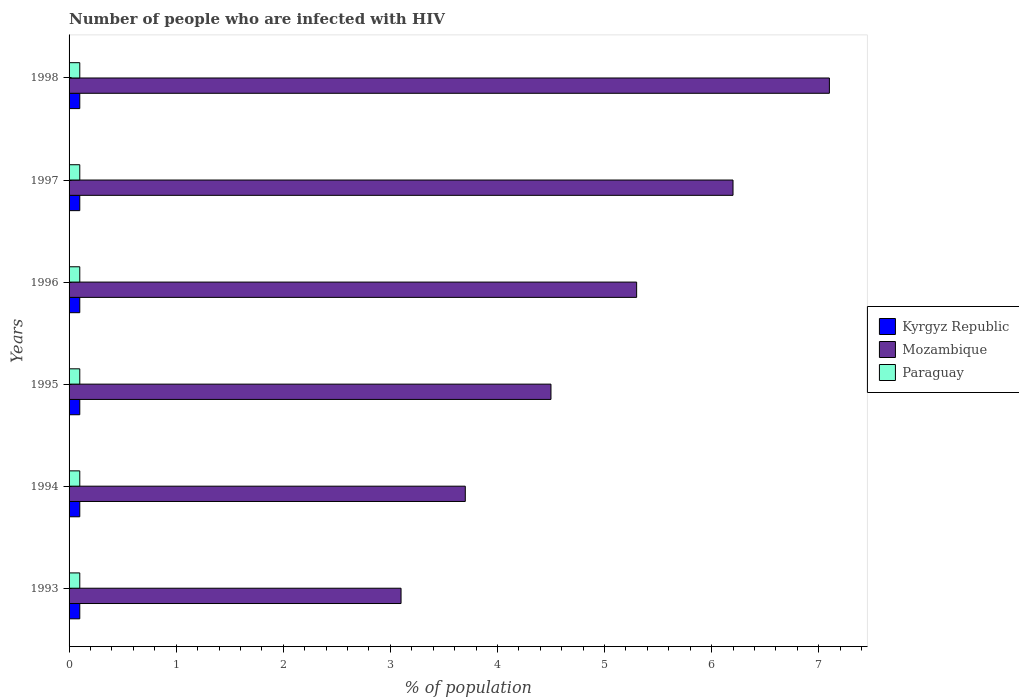How many groups of bars are there?
Offer a very short reply. 6. Are the number of bars per tick equal to the number of legend labels?
Your answer should be compact. Yes. Are the number of bars on each tick of the Y-axis equal?
Your response must be concise. Yes. How many bars are there on the 3rd tick from the top?
Give a very brief answer. 3. In how many cases, is the number of bars for a given year not equal to the number of legend labels?
Give a very brief answer. 0. What is the percentage of HIV infected population in in Kyrgyz Republic in 1994?
Make the answer very short. 0.1. Across all years, what is the maximum percentage of HIV infected population in in Mozambique?
Give a very brief answer. 7.1. Across all years, what is the minimum percentage of HIV infected population in in Kyrgyz Republic?
Keep it short and to the point. 0.1. What is the difference between the percentage of HIV infected population in in Kyrgyz Republic in 1998 and the percentage of HIV infected population in in Paraguay in 1997?
Give a very brief answer. 0. What is the average percentage of HIV infected population in in Paraguay per year?
Offer a terse response. 0.1. In how many years, is the percentage of HIV infected population in in Mozambique greater than 4 %?
Your answer should be compact. 4. Is the percentage of HIV infected population in in Paraguay in 1994 less than that in 1995?
Ensure brevity in your answer.  No. What is the difference between the highest and the second highest percentage of HIV infected population in in Mozambique?
Offer a terse response. 0.9. What is the difference between the highest and the lowest percentage of HIV infected population in in Kyrgyz Republic?
Provide a short and direct response. 0. Is the sum of the percentage of HIV infected population in in Mozambique in 1995 and 1998 greater than the maximum percentage of HIV infected population in in Paraguay across all years?
Your response must be concise. Yes. What does the 1st bar from the top in 1995 represents?
Provide a short and direct response. Paraguay. What does the 1st bar from the bottom in 1993 represents?
Your answer should be very brief. Kyrgyz Republic. Are all the bars in the graph horizontal?
Make the answer very short. Yes. How many years are there in the graph?
Offer a very short reply. 6. Are the values on the major ticks of X-axis written in scientific E-notation?
Give a very brief answer. No. Does the graph contain grids?
Your answer should be compact. No. How are the legend labels stacked?
Your response must be concise. Vertical. What is the title of the graph?
Ensure brevity in your answer.  Number of people who are infected with HIV. Does "Belgium" appear as one of the legend labels in the graph?
Make the answer very short. No. What is the label or title of the X-axis?
Provide a succinct answer. % of population. What is the % of population of Kyrgyz Republic in 1993?
Give a very brief answer. 0.1. What is the % of population in Paraguay in 1993?
Ensure brevity in your answer.  0.1. What is the % of population in Kyrgyz Republic in 1994?
Your answer should be compact. 0.1. What is the % of population in Paraguay in 1994?
Your answer should be compact. 0.1. What is the % of population of Kyrgyz Republic in 1995?
Offer a terse response. 0.1. What is the % of population in Mozambique in 1996?
Give a very brief answer. 5.3. What is the % of population of Kyrgyz Republic in 1997?
Offer a very short reply. 0.1. What is the % of population in Paraguay in 1997?
Provide a short and direct response. 0.1. What is the % of population of Kyrgyz Republic in 1998?
Make the answer very short. 0.1. Across all years, what is the maximum % of population of Kyrgyz Republic?
Your response must be concise. 0.1. Across all years, what is the maximum % of population in Mozambique?
Offer a terse response. 7.1. Across all years, what is the minimum % of population in Paraguay?
Make the answer very short. 0.1. What is the total % of population in Kyrgyz Republic in the graph?
Provide a succinct answer. 0.6. What is the total % of population in Mozambique in the graph?
Keep it short and to the point. 29.9. What is the difference between the % of population of Kyrgyz Republic in 1993 and that in 1994?
Your response must be concise. 0. What is the difference between the % of population in Paraguay in 1993 and that in 1994?
Offer a terse response. 0. What is the difference between the % of population of Mozambique in 1993 and that in 1995?
Your answer should be compact. -1.4. What is the difference between the % of population in Kyrgyz Republic in 1993 and that in 1996?
Ensure brevity in your answer.  0. What is the difference between the % of population in Paraguay in 1993 and that in 1996?
Provide a succinct answer. 0. What is the difference between the % of population in Mozambique in 1993 and that in 1997?
Offer a terse response. -3.1. What is the difference between the % of population in Paraguay in 1993 and that in 1997?
Provide a short and direct response. 0. What is the difference between the % of population of Mozambique in 1993 and that in 1998?
Offer a terse response. -4. What is the difference between the % of population of Paraguay in 1993 and that in 1998?
Your response must be concise. 0. What is the difference between the % of population in Mozambique in 1994 and that in 1995?
Give a very brief answer. -0.8. What is the difference between the % of population in Paraguay in 1994 and that in 1995?
Provide a short and direct response. 0. What is the difference between the % of population of Kyrgyz Republic in 1994 and that in 1996?
Offer a terse response. 0. What is the difference between the % of population in Mozambique in 1994 and that in 1996?
Offer a very short reply. -1.6. What is the difference between the % of population of Paraguay in 1994 and that in 1996?
Provide a short and direct response. 0. What is the difference between the % of population of Mozambique in 1994 and that in 1997?
Your answer should be very brief. -2.5. What is the difference between the % of population in Paraguay in 1994 and that in 1997?
Offer a terse response. 0. What is the difference between the % of population in Kyrgyz Republic in 1994 and that in 1998?
Your response must be concise. 0. What is the difference between the % of population of Mozambique in 1995 and that in 1996?
Keep it short and to the point. -0.8. What is the difference between the % of population of Kyrgyz Republic in 1995 and that in 1997?
Provide a succinct answer. 0. What is the difference between the % of population in Paraguay in 1995 and that in 1997?
Your answer should be compact. 0. What is the difference between the % of population of Paraguay in 1995 and that in 1998?
Provide a short and direct response. 0. What is the difference between the % of population of Mozambique in 1996 and that in 1997?
Keep it short and to the point. -0.9. What is the difference between the % of population in Paraguay in 1996 and that in 1997?
Give a very brief answer. 0. What is the difference between the % of population of Kyrgyz Republic in 1996 and that in 1998?
Offer a very short reply. 0. What is the difference between the % of population in Mozambique in 1996 and that in 1998?
Offer a terse response. -1.8. What is the difference between the % of population of Paraguay in 1996 and that in 1998?
Your answer should be very brief. 0. What is the difference between the % of population of Mozambique in 1997 and that in 1998?
Keep it short and to the point. -0.9. What is the difference between the % of population in Paraguay in 1997 and that in 1998?
Offer a terse response. 0. What is the difference between the % of population in Kyrgyz Republic in 1993 and the % of population in Paraguay in 1995?
Provide a short and direct response. 0. What is the difference between the % of population of Kyrgyz Republic in 1993 and the % of population of Paraguay in 1996?
Keep it short and to the point. 0. What is the difference between the % of population of Kyrgyz Republic in 1993 and the % of population of Mozambique in 1997?
Your answer should be compact. -6.1. What is the difference between the % of population in Kyrgyz Republic in 1993 and the % of population in Paraguay in 1997?
Offer a terse response. 0. What is the difference between the % of population of Mozambique in 1993 and the % of population of Paraguay in 1997?
Offer a terse response. 3. What is the difference between the % of population in Kyrgyz Republic in 1993 and the % of population in Paraguay in 1998?
Offer a very short reply. 0. What is the difference between the % of population in Kyrgyz Republic in 1994 and the % of population in Mozambique in 1995?
Make the answer very short. -4.4. What is the difference between the % of population in Kyrgyz Republic in 1994 and the % of population in Paraguay in 1995?
Offer a very short reply. 0. What is the difference between the % of population in Mozambique in 1994 and the % of population in Paraguay in 1995?
Provide a succinct answer. 3.6. What is the difference between the % of population in Kyrgyz Republic in 1994 and the % of population in Paraguay in 1996?
Your answer should be very brief. 0. What is the difference between the % of population of Mozambique in 1994 and the % of population of Paraguay in 1996?
Your answer should be compact. 3.6. What is the difference between the % of population in Kyrgyz Republic in 1994 and the % of population in Mozambique in 1997?
Make the answer very short. -6.1. What is the difference between the % of population of Kyrgyz Republic in 1994 and the % of population of Paraguay in 1997?
Make the answer very short. 0. What is the difference between the % of population of Kyrgyz Republic in 1994 and the % of population of Paraguay in 1998?
Provide a succinct answer. 0. What is the difference between the % of population of Mozambique in 1994 and the % of population of Paraguay in 1998?
Your answer should be very brief. 3.6. What is the difference between the % of population in Kyrgyz Republic in 1995 and the % of population in Mozambique in 1996?
Keep it short and to the point. -5.2. What is the difference between the % of population of Kyrgyz Republic in 1995 and the % of population of Paraguay in 1996?
Ensure brevity in your answer.  0. What is the difference between the % of population in Kyrgyz Republic in 1995 and the % of population in Paraguay in 1997?
Your answer should be very brief. 0. What is the difference between the % of population in Mozambique in 1995 and the % of population in Paraguay in 1997?
Provide a short and direct response. 4.4. What is the difference between the % of population of Kyrgyz Republic in 1996 and the % of population of Paraguay in 1997?
Provide a succinct answer. 0. What is the difference between the % of population of Kyrgyz Republic in 1996 and the % of population of Mozambique in 1998?
Give a very brief answer. -7. What is the difference between the % of population in Kyrgyz Republic in 1996 and the % of population in Paraguay in 1998?
Your answer should be compact. 0. What is the difference between the % of population in Kyrgyz Republic in 1997 and the % of population in Mozambique in 1998?
Give a very brief answer. -7. What is the average % of population in Kyrgyz Republic per year?
Make the answer very short. 0.1. What is the average % of population in Mozambique per year?
Keep it short and to the point. 4.98. What is the average % of population of Paraguay per year?
Give a very brief answer. 0.1. In the year 1993, what is the difference between the % of population in Kyrgyz Republic and % of population in Paraguay?
Provide a short and direct response. 0. In the year 1994, what is the difference between the % of population in Kyrgyz Republic and % of population in Mozambique?
Offer a terse response. -3.6. In the year 1994, what is the difference between the % of population of Kyrgyz Republic and % of population of Paraguay?
Give a very brief answer. 0. In the year 1994, what is the difference between the % of population in Mozambique and % of population in Paraguay?
Your answer should be very brief. 3.6. In the year 1995, what is the difference between the % of population in Mozambique and % of population in Paraguay?
Your response must be concise. 4.4. In the year 1997, what is the difference between the % of population in Kyrgyz Republic and % of population in Mozambique?
Your response must be concise. -6.1. In the year 1997, what is the difference between the % of population of Kyrgyz Republic and % of population of Paraguay?
Your answer should be very brief. 0. In the year 1998, what is the difference between the % of population in Kyrgyz Republic and % of population in Paraguay?
Your answer should be compact. 0. What is the ratio of the % of population of Mozambique in 1993 to that in 1994?
Your response must be concise. 0.84. What is the ratio of the % of population in Kyrgyz Republic in 1993 to that in 1995?
Offer a very short reply. 1. What is the ratio of the % of population in Mozambique in 1993 to that in 1995?
Your answer should be very brief. 0.69. What is the ratio of the % of population in Paraguay in 1993 to that in 1995?
Offer a terse response. 1. What is the ratio of the % of population of Mozambique in 1993 to that in 1996?
Ensure brevity in your answer.  0.58. What is the ratio of the % of population in Kyrgyz Republic in 1993 to that in 1997?
Make the answer very short. 1. What is the ratio of the % of population of Mozambique in 1993 to that in 1997?
Offer a terse response. 0.5. What is the ratio of the % of population of Kyrgyz Republic in 1993 to that in 1998?
Give a very brief answer. 1. What is the ratio of the % of population in Mozambique in 1993 to that in 1998?
Make the answer very short. 0.44. What is the ratio of the % of population of Paraguay in 1993 to that in 1998?
Make the answer very short. 1. What is the ratio of the % of population in Mozambique in 1994 to that in 1995?
Offer a terse response. 0.82. What is the ratio of the % of population of Paraguay in 1994 to that in 1995?
Ensure brevity in your answer.  1. What is the ratio of the % of population in Kyrgyz Republic in 1994 to that in 1996?
Ensure brevity in your answer.  1. What is the ratio of the % of population of Mozambique in 1994 to that in 1996?
Ensure brevity in your answer.  0.7. What is the ratio of the % of population in Kyrgyz Republic in 1994 to that in 1997?
Your response must be concise. 1. What is the ratio of the % of population of Mozambique in 1994 to that in 1997?
Offer a very short reply. 0.6. What is the ratio of the % of population in Paraguay in 1994 to that in 1997?
Provide a short and direct response. 1. What is the ratio of the % of population in Mozambique in 1994 to that in 1998?
Give a very brief answer. 0.52. What is the ratio of the % of population in Kyrgyz Republic in 1995 to that in 1996?
Your answer should be very brief. 1. What is the ratio of the % of population in Mozambique in 1995 to that in 1996?
Your answer should be very brief. 0.85. What is the ratio of the % of population of Kyrgyz Republic in 1995 to that in 1997?
Your response must be concise. 1. What is the ratio of the % of population in Mozambique in 1995 to that in 1997?
Give a very brief answer. 0.73. What is the ratio of the % of population of Mozambique in 1995 to that in 1998?
Offer a terse response. 0.63. What is the ratio of the % of population in Mozambique in 1996 to that in 1997?
Keep it short and to the point. 0.85. What is the ratio of the % of population of Kyrgyz Republic in 1996 to that in 1998?
Make the answer very short. 1. What is the ratio of the % of population of Mozambique in 1996 to that in 1998?
Offer a very short reply. 0.75. What is the ratio of the % of population in Kyrgyz Republic in 1997 to that in 1998?
Your response must be concise. 1. What is the ratio of the % of population of Mozambique in 1997 to that in 1998?
Your answer should be compact. 0.87. What is the difference between the highest and the second highest % of population of Kyrgyz Republic?
Ensure brevity in your answer.  0. What is the difference between the highest and the second highest % of population of Paraguay?
Your response must be concise. 0. What is the difference between the highest and the lowest % of population of Mozambique?
Your response must be concise. 4. What is the difference between the highest and the lowest % of population in Paraguay?
Offer a terse response. 0. 